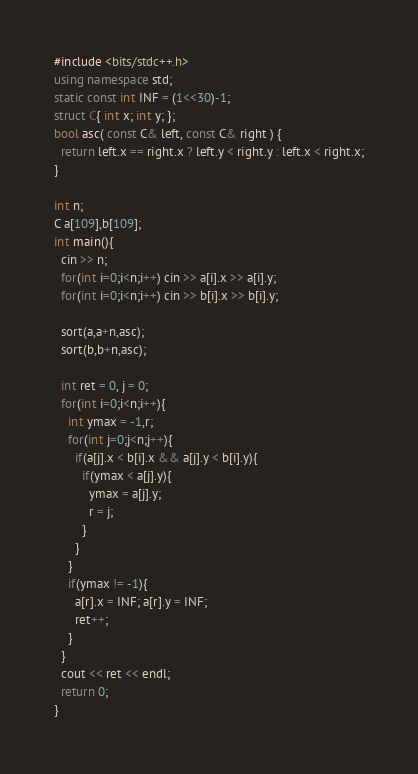<code> <loc_0><loc_0><loc_500><loc_500><_C++_>#include <bits/stdc++.h>
using namespace std;
static const int INF = (1<<30)-1;
struct C{ int x; int y; };
bool asc( const C& left, const C& right ) {
  return left.x == right.x ? left.y < right.y : left.x < right.x;
}

int n;
C a[109],b[109];
int main(){
  cin >> n;
  for(int i=0;i<n;i++) cin >> a[i].x >> a[i].y;
  for(int i=0;i<n;i++) cin >> b[i].x >> b[i].y;

  sort(a,a+n,asc);
  sort(b,b+n,asc);

  int ret = 0, j = 0;
  for(int i=0;i<n;i++){
    int ymax = -1,r;
    for(int j=0;j<n;j++){
      if(a[j].x < b[i].x && a[j].y < b[i].y){
        if(ymax < a[j].y){
          ymax = a[j].y;
          r = j;
        }
      }
    }
    if(ymax != -1){
      a[r].x = INF; a[r].y = INF;
      ret++;
    }
  }
  cout << ret << endl;
  return 0;
}
</code> 